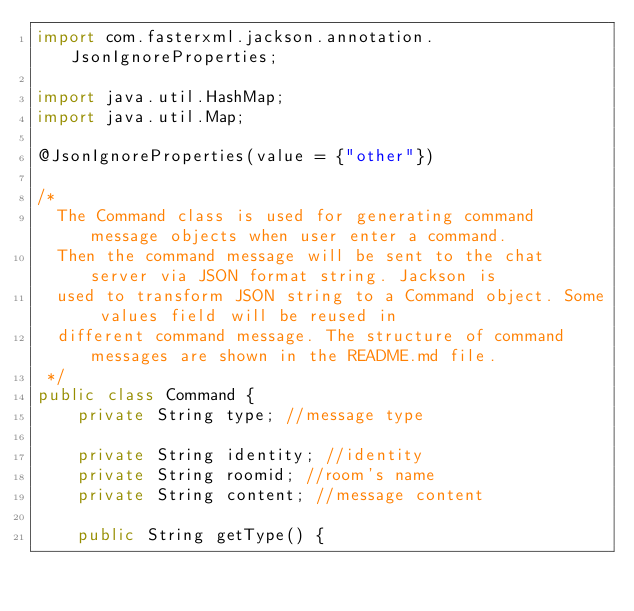Convert code to text. <code><loc_0><loc_0><loc_500><loc_500><_Java_>import com.fasterxml.jackson.annotation.JsonIgnoreProperties;

import java.util.HashMap;
import java.util.Map;

@JsonIgnoreProperties(value = {"other"})

/*
  The Command class is used for generating command message objects when user enter a command.
  Then the command message will be sent to the chat server via JSON format string. Jackson is
  used to transform JSON string to a Command object. Some values field will be reused in
  different command message. The structure of command messages are shown in the README.md file.
 */
public class Command {
    private String type; //message type

    private String identity; //identity
    private String roomid; //room's name
    private String content; //message content

    public String getType() {</code> 